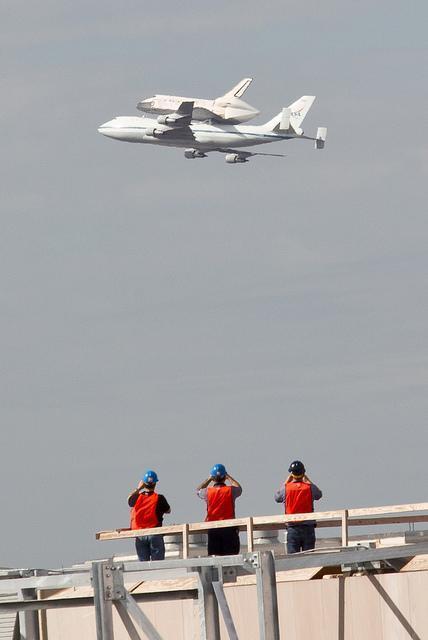How many blue hard hats are there?
Give a very brief answer. 2. How many people are there?
Give a very brief answer. 3. How many pieces is the pizza cut into?
Give a very brief answer. 0. 